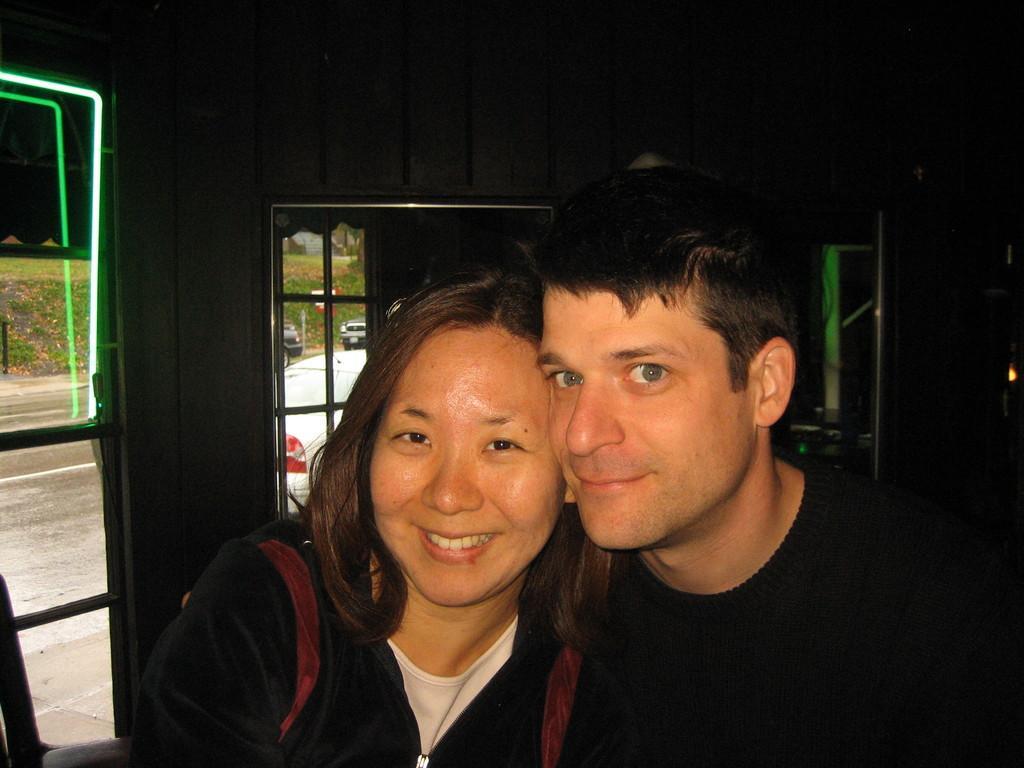How would you summarize this image in a sentence or two? In this image I can see the two people with black and white color dresses. In the background I can see the windows. Through the windows I can see the vehicles on the road and the grass. 